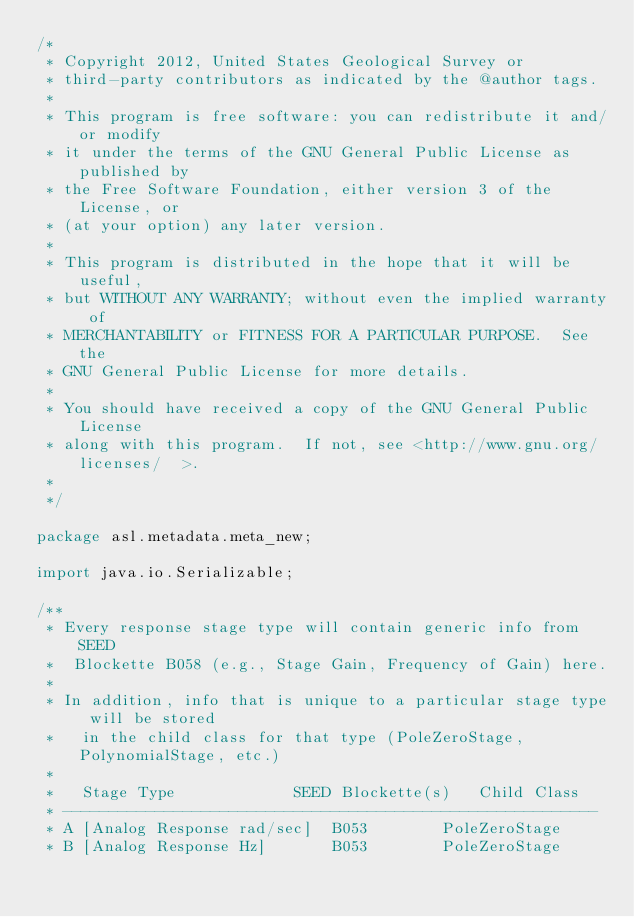Convert code to text. <code><loc_0><loc_0><loc_500><loc_500><_Java_>/*
 * Copyright 2012, United States Geological Survey or
 * third-party contributors as indicated by the @author tags.
 *
 * This program is free software: you can redistribute it and/or modify
 * it under the terms of the GNU General Public License as published by
 * the Free Software Foundation, either version 3 of the License, or
 * (at your option) any later version.
 *
 * This program is distributed in the hope that it will be useful,
 * but WITHOUT ANY WARRANTY; without even the implied warranty of
 * MERCHANTABILITY or FITNESS FOR A PARTICULAR PURPOSE.  See the
 * GNU General Public License for more details.
 *
 * You should have received a copy of the GNU General Public License
 * along with this program.  If not, see <http://www.gnu.org/licenses/  >.
 *
 */

package asl.metadata.meta_new;

import java.io.Serializable;

/** 
 * Every response stage type will contain generic info from SEED 
 *  Blockette B058 (e.g., Stage Gain, Frequency of Gain) here.
 * 
 * In addition, info that is unique to a particular stage type will be stored 
 *   in the child class for that type (PoleZeroStage, PolynomialStage, etc.)
 *
 *   Stage Type             SEED Blockette(s)   Child Class
 * ----------------------------------------------------------
 * A [Analog Response rad/sec]  B053        PoleZeroStage
 * B [Analog Response Hz]       B053        PoleZeroStage</code> 